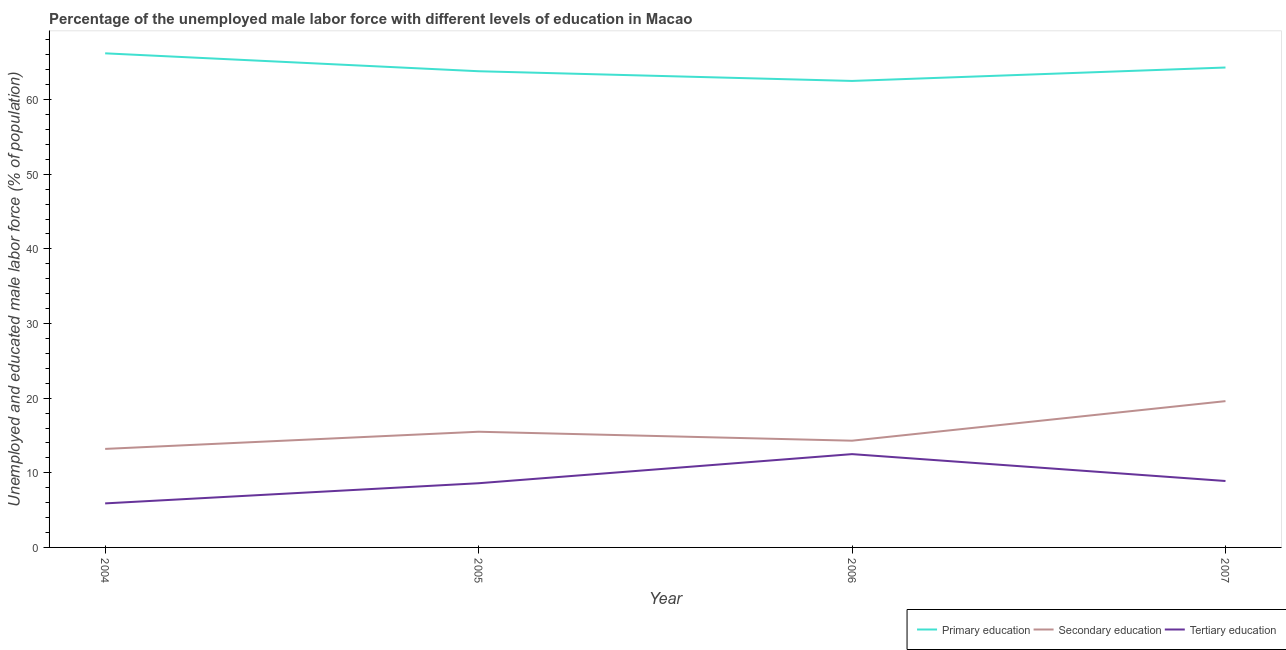How many different coloured lines are there?
Ensure brevity in your answer.  3. Is the number of lines equal to the number of legend labels?
Give a very brief answer. Yes. What is the percentage of male labor force who received primary education in 2005?
Make the answer very short. 63.8. Across all years, what is the maximum percentage of male labor force who received primary education?
Your answer should be very brief. 66.2. Across all years, what is the minimum percentage of male labor force who received tertiary education?
Give a very brief answer. 5.9. In which year was the percentage of male labor force who received secondary education minimum?
Offer a terse response. 2004. What is the total percentage of male labor force who received tertiary education in the graph?
Offer a terse response. 35.9. What is the difference between the percentage of male labor force who received tertiary education in 2004 and that in 2007?
Keep it short and to the point. -3. What is the difference between the percentage of male labor force who received secondary education in 2006 and the percentage of male labor force who received primary education in 2004?
Provide a succinct answer. -51.9. What is the average percentage of male labor force who received tertiary education per year?
Keep it short and to the point. 8.98. In the year 2006, what is the difference between the percentage of male labor force who received secondary education and percentage of male labor force who received tertiary education?
Offer a very short reply. 1.8. In how many years, is the percentage of male labor force who received secondary education greater than 30 %?
Ensure brevity in your answer.  0. What is the ratio of the percentage of male labor force who received secondary education in 2004 to that in 2007?
Provide a short and direct response. 0.67. Is the difference between the percentage of male labor force who received tertiary education in 2004 and 2007 greater than the difference between the percentage of male labor force who received secondary education in 2004 and 2007?
Provide a succinct answer. Yes. What is the difference between the highest and the second highest percentage of male labor force who received tertiary education?
Your answer should be very brief. 3.6. What is the difference between the highest and the lowest percentage of male labor force who received primary education?
Provide a succinct answer. 3.7. Is it the case that in every year, the sum of the percentage of male labor force who received primary education and percentage of male labor force who received secondary education is greater than the percentage of male labor force who received tertiary education?
Keep it short and to the point. Yes. Is the percentage of male labor force who received primary education strictly greater than the percentage of male labor force who received tertiary education over the years?
Your answer should be compact. Yes. What is the difference between two consecutive major ticks on the Y-axis?
Make the answer very short. 10. Does the graph contain grids?
Your answer should be very brief. No. What is the title of the graph?
Give a very brief answer. Percentage of the unemployed male labor force with different levels of education in Macao. What is the label or title of the X-axis?
Keep it short and to the point. Year. What is the label or title of the Y-axis?
Give a very brief answer. Unemployed and educated male labor force (% of population). What is the Unemployed and educated male labor force (% of population) of Primary education in 2004?
Keep it short and to the point. 66.2. What is the Unemployed and educated male labor force (% of population) in Secondary education in 2004?
Your response must be concise. 13.2. What is the Unemployed and educated male labor force (% of population) in Tertiary education in 2004?
Offer a terse response. 5.9. What is the Unemployed and educated male labor force (% of population) in Primary education in 2005?
Your answer should be very brief. 63.8. What is the Unemployed and educated male labor force (% of population) of Secondary education in 2005?
Provide a short and direct response. 15.5. What is the Unemployed and educated male labor force (% of population) in Tertiary education in 2005?
Your answer should be very brief. 8.6. What is the Unemployed and educated male labor force (% of population) of Primary education in 2006?
Keep it short and to the point. 62.5. What is the Unemployed and educated male labor force (% of population) of Secondary education in 2006?
Keep it short and to the point. 14.3. What is the Unemployed and educated male labor force (% of population) of Primary education in 2007?
Ensure brevity in your answer.  64.3. What is the Unemployed and educated male labor force (% of population) of Secondary education in 2007?
Provide a succinct answer. 19.6. What is the Unemployed and educated male labor force (% of population) of Tertiary education in 2007?
Your answer should be very brief. 8.9. Across all years, what is the maximum Unemployed and educated male labor force (% of population) of Primary education?
Make the answer very short. 66.2. Across all years, what is the maximum Unemployed and educated male labor force (% of population) in Secondary education?
Offer a terse response. 19.6. Across all years, what is the maximum Unemployed and educated male labor force (% of population) of Tertiary education?
Your answer should be compact. 12.5. Across all years, what is the minimum Unemployed and educated male labor force (% of population) in Primary education?
Keep it short and to the point. 62.5. Across all years, what is the minimum Unemployed and educated male labor force (% of population) of Secondary education?
Offer a very short reply. 13.2. Across all years, what is the minimum Unemployed and educated male labor force (% of population) in Tertiary education?
Offer a terse response. 5.9. What is the total Unemployed and educated male labor force (% of population) in Primary education in the graph?
Your answer should be compact. 256.8. What is the total Unemployed and educated male labor force (% of population) in Secondary education in the graph?
Your response must be concise. 62.6. What is the total Unemployed and educated male labor force (% of population) of Tertiary education in the graph?
Give a very brief answer. 35.9. What is the difference between the Unemployed and educated male labor force (% of population) in Secondary education in 2004 and that in 2005?
Offer a terse response. -2.3. What is the difference between the Unemployed and educated male labor force (% of population) of Primary education in 2004 and that in 2006?
Provide a short and direct response. 3.7. What is the difference between the Unemployed and educated male labor force (% of population) in Secondary education in 2004 and that in 2006?
Provide a short and direct response. -1.1. What is the difference between the Unemployed and educated male labor force (% of population) in Tertiary education in 2004 and that in 2006?
Ensure brevity in your answer.  -6.6. What is the difference between the Unemployed and educated male labor force (% of population) of Primary education in 2004 and that in 2007?
Offer a very short reply. 1.9. What is the difference between the Unemployed and educated male labor force (% of population) in Secondary education in 2004 and that in 2007?
Your answer should be compact. -6.4. What is the difference between the Unemployed and educated male labor force (% of population) in Tertiary education in 2004 and that in 2007?
Give a very brief answer. -3. What is the difference between the Unemployed and educated male labor force (% of population) of Secondary education in 2005 and that in 2006?
Your answer should be very brief. 1.2. What is the difference between the Unemployed and educated male labor force (% of population) of Secondary education in 2005 and that in 2007?
Provide a short and direct response. -4.1. What is the difference between the Unemployed and educated male labor force (% of population) in Secondary education in 2006 and that in 2007?
Your response must be concise. -5.3. What is the difference between the Unemployed and educated male labor force (% of population) of Tertiary education in 2006 and that in 2007?
Provide a succinct answer. 3.6. What is the difference between the Unemployed and educated male labor force (% of population) of Primary education in 2004 and the Unemployed and educated male labor force (% of population) of Secondary education in 2005?
Your answer should be compact. 50.7. What is the difference between the Unemployed and educated male labor force (% of population) of Primary education in 2004 and the Unemployed and educated male labor force (% of population) of Tertiary education in 2005?
Your answer should be very brief. 57.6. What is the difference between the Unemployed and educated male labor force (% of population) of Secondary education in 2004 and the Unemployed and educated male labor force (% of population) of Tertiary education in 2005?
Offer a very short reply. 4.6. What is the difference between the Unemployed and educated male labor force (% of population) of Primary education in 2004 and the Unemployed and educated male labor force (% of population) of Secondary education in 2006?
Keep it short and to the point. 51.9. What is the difference between the Unemployed and educated male labor force (% of population) of Primary education in 2004 and the Unemployed and educated male labor force (% of population) of Tertiary education in 2006?
Your response must be concise. 53.7. What is the difference between the Unemployed and educated male labor force (% of population) in Secondary education in 2004 and the Unemployed and educated male labor force (% of population) in Tertiary education in 2006?
Keep it short and to the point. 0.7. What is the difference between the Unemployed and educated male labor force (% of population) of Primary education in 2004 and the Unemployed and educated male labor force (% of population) of Secondary education in 2007?
Ensure brevity in your answer.  46.6. What is the difference between the Unemployed and educated male labor force (% of population) of Primary education in 2004 and the Unemployed and educated male labor force (% of population) of Tertiary education in 2007?
Keep it short and to the point. 57.3. What is the difference between the Unemployed and educated male labor force (% of population) of Secondary education in 2004 and the Unemployed and educated male labor force (% of population) of Tertiary education in 2007?
Provide a succinct answer. 4.3. What is the difference between the Unemployed and educated male labor force (% of population) in Primary education in 2005 and the Unemployed and educated male labor force (% of population) in Secondary education in 2006?
Your answer should be compact. 49.5. What is the difference between the Unemployed and educated male labor force (% of population) in Primary education in 2005 and the Unemployed and educated male labor force (% of population) in Tertiary education in 2006?
Your answer should be compact. 51.3. What is the difference between the Unemployed and educated male labor force (% of population) in Secondary education in 2005 and the Unemployed and educated male labor force (% of population) in Tertiary education in 2006?
Your answer should be very brief. 3. What is the difference between the Unemployed and educated male labor force (% of population) in Primary education in 2005 and the Unemployed and educated male labor force (% of population) in Secondary education in 2007?
Provide a short and direct response. 44.2. What is the difference between the Unemployed and educated male labor force (% of population) in Primary education in 2005 and the Unemployed and educated male labor force (% of population) in Tertiary education in 2007?
Your response must be concise. 54.9. What is the difference between the Unemployed and educated male labor force (% of population) of Secondary education in 2005 and the Unemployed and educated male labor force (% of population) of Tertiary education in 2007?
Your answer should be very brief. 6.6. What is the difference between the Unemployed and educated male labor force (% of population) in Primary education in 2006 and the Unemployed and educated male labor force (% of population) in Secondary education in 2007?
Provide a succinct answer. 42.9. What is the difference between the Unemployed and educated male labor force (% of population) in Primary education in 2006 and the Unemployed and educated male labor force (% of population) in Tertiary education in 2007?
Ensure brevity in your answer.  53.6. What is the difference between the Unemployed and educated male labor force (% of population) in Secondary education in 2006 and the Unemployed and educated male labor force (% of population) in Tertiary education in 2007?
Make the answer very short. 5.4. What is the average Unemployed and educated male labor force (% of population) in Primary education per year?
Give a very brief answer. 64.2. What is the average Unemployed and educated male labor force (% of population) of Secondary education per year?
Give a very brief answer. 15.65. What is the average Unemployed and educated male labor force (% of population) of Tertiary education per year?
Offer a very short reply. 8.97. In the year 2004, what is the difference between the Unemployed and educated male labor force (% of population) in Primary education and Unemployed and educated male labor force (% of population) in Secondary education?
Provide a succinct answer. 53. In the year 2004, what is the difference between the Unemployed and educated male labor force (% of population) in Primary education and Unemployed and educated male labor force (% of population) in Tertiary education?
Provide a succinct answer. 60.3. In the year 2004, what is the difference between the Unemployed and educated male labor force (% of population) in Secondary education and Unemployed and educated male labor force (% of population) in Tertiary education?
Give a very brief answer. 7.3. In the year 2005, what is the difference between the Unemployed and educated male labor force (% of population) in Primary education and Unemployed and educated male labor force (% of population) in Secondary education?
Ensure brevity in your answer.  48.3. In the year 2005, what is the difference between the Unemployed and educated male labor force (% of population) in Primary education and Unemployed and educated male labor force (% of population) in Tertiary education?
Offer a very short reply. 55.2. In the year 2006, what is the difference between the Unemployed and educated male labor force (% of population) in Primary education and Unemployed and educated male labor force (% of population) in Secondary education?
Your answer should be compact. 48.2. In the year 2006, what is the difference between the Unemployed and educated male labor force (% of population) of Primary education and Unemployed and educated male labor force (% of population) of Tertiary education?
Keep it short and to the point. 50. In the year 2006, what is the difference between the Unemployed and educated male labor force (% of population) of Secondary education and Unemployed and educated male labor force (% of population) of Tertiary education?
Keep it short and to the point. 1.8. In the year 2007, what is the difference between the Unemployed and educated male labor force (% of population) of Primary education and Unemployed and educated male labor force (% of population) of Secondary education?
Keep it short and to the point. 44.7. In the year 2007, what is the difference between the Unemployed and educated male labor force (% of population) in Primary education and Unemployed and educated male labor force (% of population) in Tertiary education?
Ensure brevity in your answer.  55.4. In the year 2007, what is the difference between the Unemployed and educated male labor force (% of population) of Secondary education and Unemployed and educated male labor force (% of population) of Tertiary education?
Keep it short and to the point. 10.7. What is the ratio of the Unemployed and educated male labor force (% of population) in Primary education in 2004 to that in 2005?
Offer a terse response. 1.04. What is the ratio of the Unemployed and educated male labor force (% of population) of Secondary education in 2004 to that in 2005?
Offer a very short reply. 0.85. What is the ratio of the Unemployed and educated male labor force (% of population) in Tertiary education in 2004 to that in 2005?
Your answer should be very brief. 0.69. What is the ratio of the Unemployed and educated male labor force (% of population) of Primary education in 2004 to that in 2006?
Your answer should be compact. 1.06. What is the ratio of the Unemployed and educated male labor force (% of population) of Secondary education in 2004 to that in 2006?
Your answer should be compact. 0.92. What is the ratio of the Unemployed and educated male labor force (% of population) of Tertiary education in 2004 to that in 2006?
Offer a terse response. 0.47. What is the ratio of the Unemployed and educated male labor force (% of population) of Primary education in 2004 to that in 2007?
Offer a terse response. 1.03. What is the ratio of the Unemployed and educated male labor force (% of population) in Secondary education in 2004 to that in 2007?
Make the answer very short. 0.67. What is the ratio of the Unemployed and educated male labor force (% of population) of Tertiary education in 2004 to that in 2007?
Keep it short and to the point. 0.66. What is the ratio of the Unemployed and educated male labor force (% of population) of Primary education in 2005 to that in 2006?
Provide a short and direct response. 1.02. What is the ratio of the Unemployed and educated male labor force (% of population) of Secondary education in 2005 to that in 2006?
Offer a terse response. 1.08. What is the ratio of the Unemployed and educated male labor force (% of population) of Tertiary education in 2005 to that in 2006?
Give a very brief answer. 0.69. What is the ratio of the Unemployed and educated male labor force (% of population) in Secondary education in 2005 to that in 2007?
Offer a very short reply. 0.79. What is the ratio of the Unemployed and educated male labor force (% of population) in Tertiary education in 2005 to that in 2007?
Provide a short and direct response. 0.97. What is the ratio of the Unemployed and educated male labor force (% of population) in Primary education in 2006 to that in 2007?
Give a very brief answer. 0.97. What is the ratio of the Unemployed and educated male labor force (% of population) of Secondary education in 2006 to that in 2007?
Your answer should be very brief. 0.73. What is the ratio of the Unemployed and educated male labor force (% of population) in Tertiary education in 2006 to that in 2007?
Provide a succinct answer. 1.4. What is the difference between the highest and the second highest Unemployed and educated male labor force (% of population) of Tertiary education?
Your response must be concise. 3.6. 